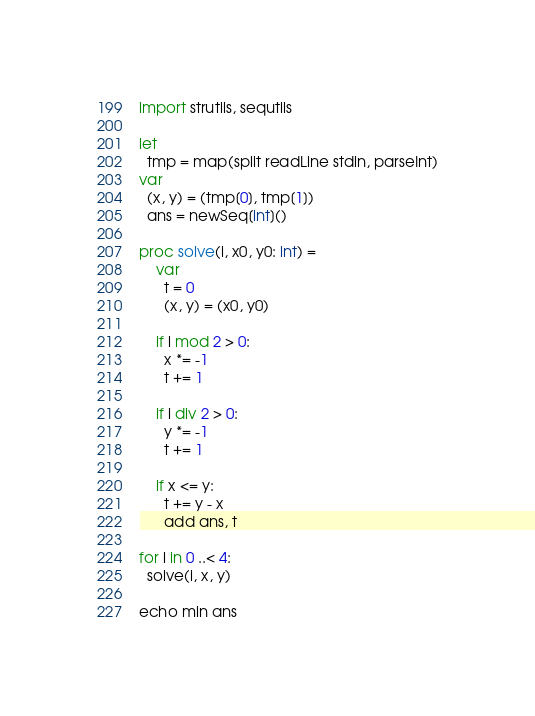Convert code to text. <code><loc_0><loc_0><loc_500><loc_500><_Nim_>import strutils, sequtils

let
  tmp = map(split readLine stdin, parseInt)
var
  (x, y) = (tmp[0], tmp[1])
  ans = newSeq[int]()

proc solve(i, x0, y0: int) =
    var
      t = 0
      (x, y) = (x0, y0)

    if i mod 2 > 0:
      x *= -1
      t += 1

    if i div 2 > 0:
      y *= -1
      t += 1

    if x <= y:
      t += y - x
      add ans, t

for i in 0 ..< 4:
  solve(i, x, y)

echo min ans
</code> 